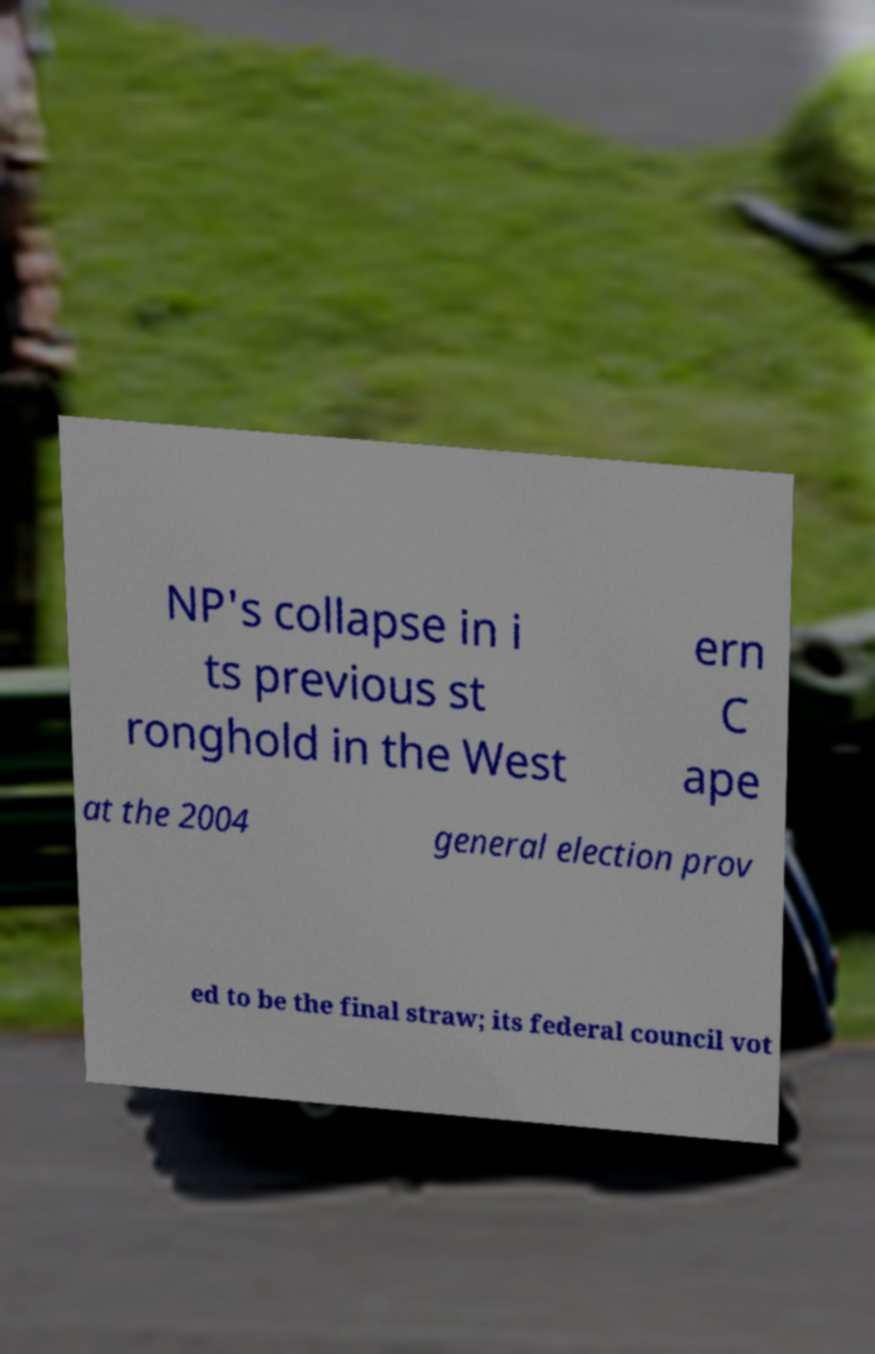For documentation purposes, I need the text within this image transcribed. Could you provide that? NP's collapse in i ts previous st ronghold in the West ern C ape at the 2004 general election prov ed to be the final straw; its federal council vot 